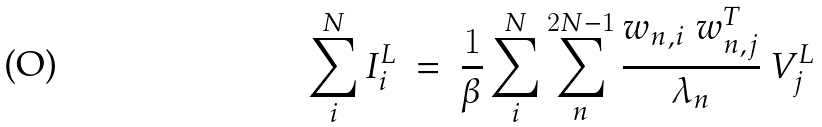<formula> <loc_0><loc_0><loc_500><loc_500>\sum ^ { N } _ { i } I ^ { L } _ { i } \ = \ \frac { 1 } { \beta } \sum ^ { N } _ { i } \sum ^ { 2 N - 1 } _ { n } \frac { w _ { n , i } \ w ^ { T } _ { n , j } } { \lambda _ { n } } \ V ^ { L } _ { j }</formula> 